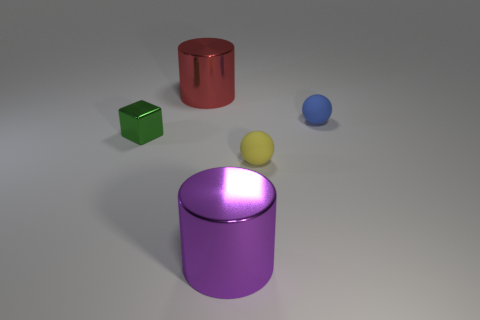Is the shape of the large thing left of the purple metallic object the same as the matte thing right of the small yellow rubber sphere?
Provide a succinct answer. No. What number of other things are the same material as the cube?
Offer a very short reply. 2. What is the shape of the large red thing that is the same material as the small cube?
Provide a short and direct response. Cylinder. Do the green shiny block and the blue object have the same size?
Your response must be concise. Yes. There is a thing to the left of the big metal cylinder on the left side of the purple shiny thing; what is its size?
Make the answer very short. Small. How many cylinders are green metallic things or blue matte things?
Your answer should be very brief. 0. There is a red metallic cylinder; is it the same size as the metal object that is in front of the yellow object?
Offer a very short reply. Yes. Are there more tiny spheres that are on the right side of the large purple shiny cylinder than tiny metallic objects?
Give a very brief answer. Yes. There is a block that is made of the same material as the red thing; what is its size?
Make the answer very short. Small. What number of objects are big red metallic objects or cylinders that are in front of the big red metal thing?
Offer a terse response. 2. 